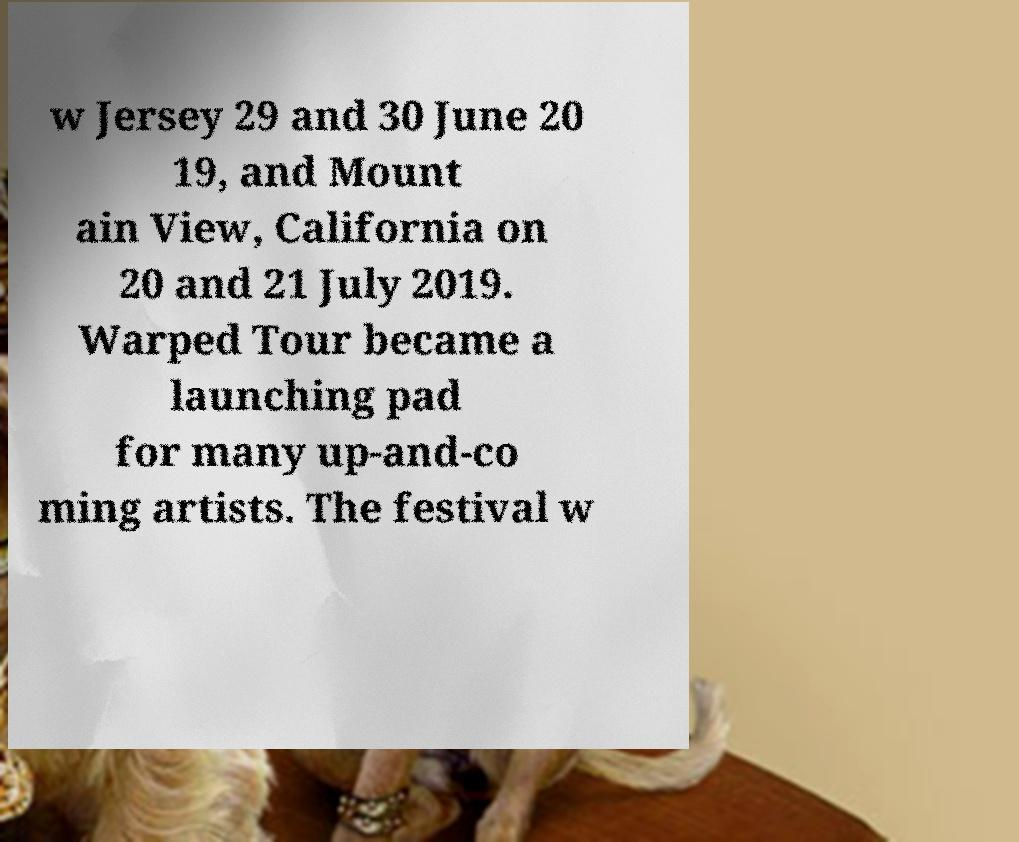Could you extract and type out the text from this image? w Jersey 29 and 30 June 20 19, and Mount ain View, California on 20 and 21 July 2019. Warped Tour became a launching pad for many up-and-co ming artists. The festival w 